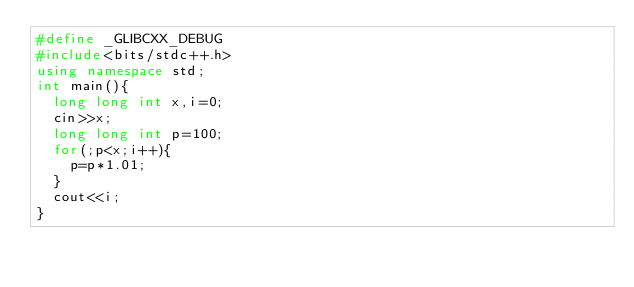Convert code to text. <code><loc_0><loc_0><loc_500><loc_500><_C++_>#define _GLIBCXX_DEBUG
#include<bits/stdc++.h>
using namespace std;
int main(){
  long long int x,i=0;
  cin>>x;
  long long int p=100;
  for(;p<x;i++){
    p=p*1.01;
  }
  cout<<i;
}
</code> 